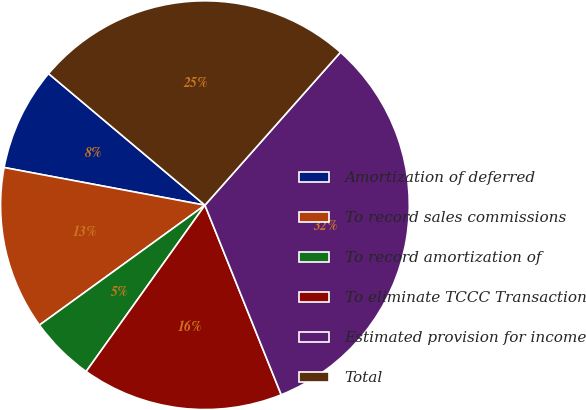<chart> <loc_0><loc_0><loc_500><loc_500><pie_chart><fcel>Amortization of deferred<fcel>To record sales commissions<fcel>To record amortization of<fcel>To eliminate TCCC Transaction<fcel>Estimated provision for income<fcel>Total<nl><fcel>8.18%<fcel>12.93%<fcel>5.15%<fcel>15.96%<fcel>32.37%<fcel>25.41%<nl></chart> 